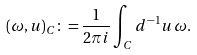<formula> <loc_0><loc_0><loc_500><loc_500>( \omega , u ) _ { C } \colon = \frac { 1 } { 2 \pi i } \int _ { C } d ^ { - 1 } u \, \omega .</formula> 